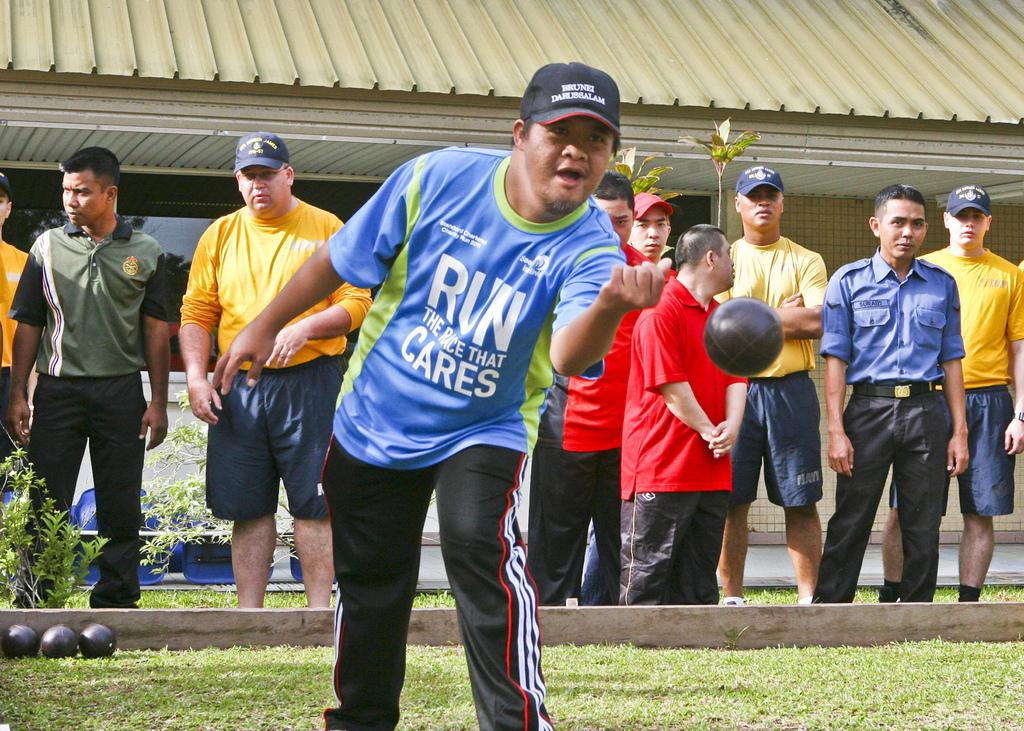Provide a one-sentence caption for the provided image. Athlete featured is playing Bocce Ball, his shirt says Run The Race that Cares. 